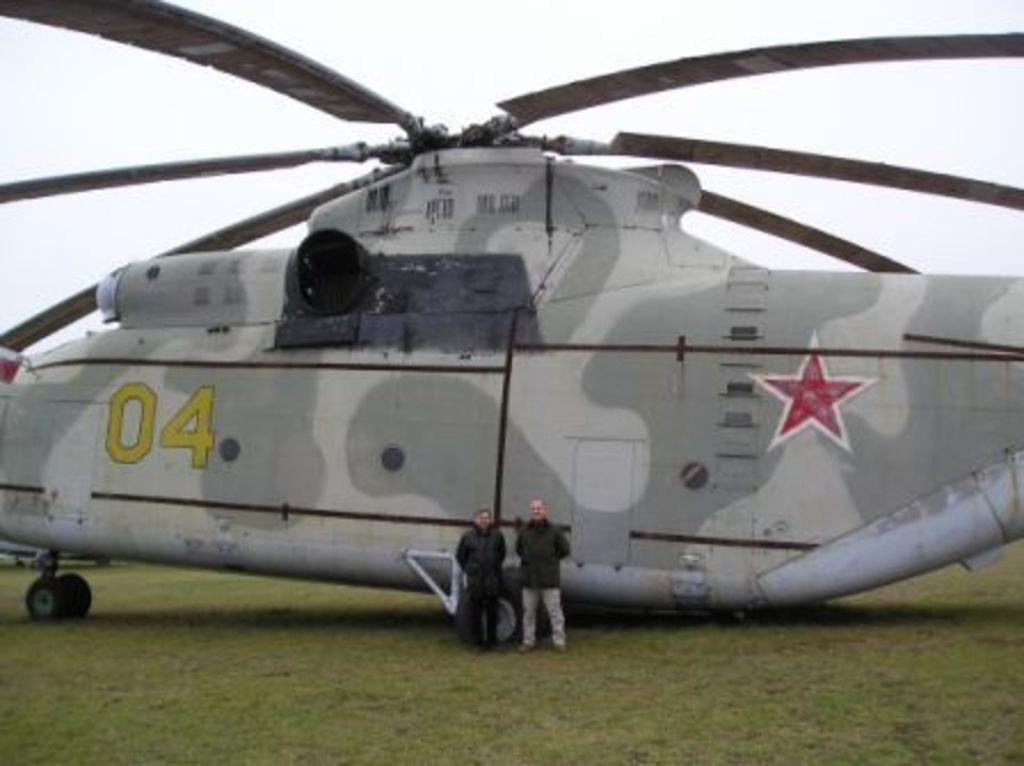<image>
Give a short and clear explanation of the subsequent image. Two people standing in front of a huge chopper with the numbers 04 on it. 